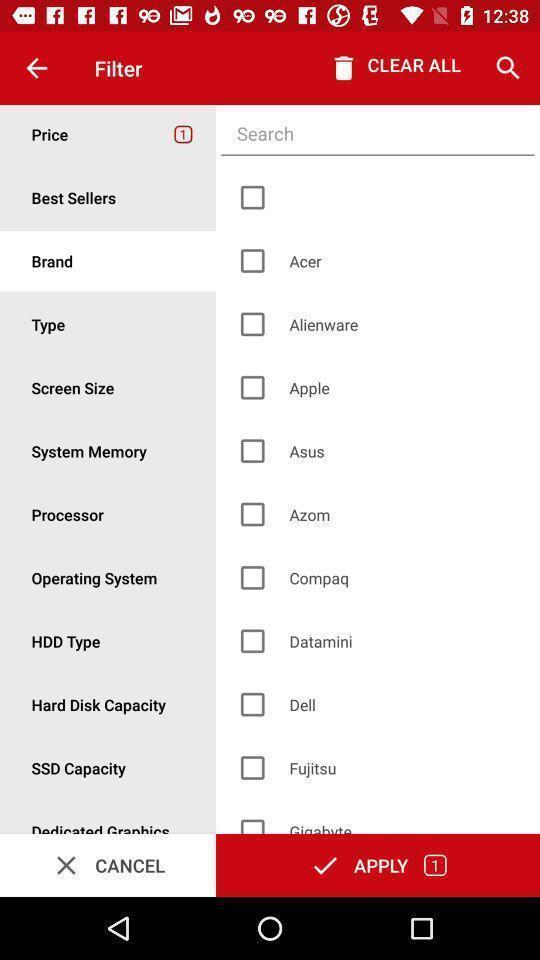Summarize the main components in this picture. Search bar to search different brands. 